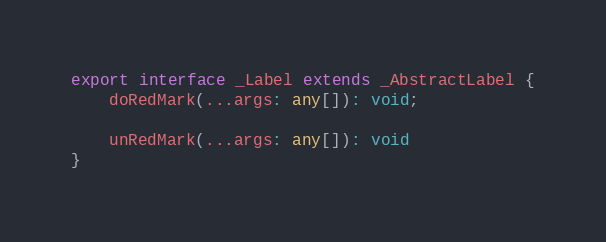<code> <loc_0><loc_0><loc_500><loc_500><_TypeScript_>
export interface _Label extends _AbstractLabel {
    doRedMark(...args: any[]): void;

    unRedMark(...args: any[]): void
}
</code> 